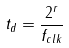Convert formula to latex. <formula><loc_0><loc_0><loc_500><loc_500>t _ { d } = \frac { 2 ^ { r } } { f _ { c l k } }</formula> 